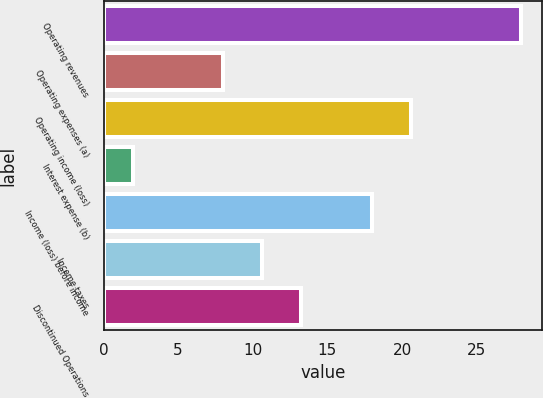Convert chart. <chart><loc_0><loc_0><loc_500><loc_500><bar_chart><fcel>Operating revenues<fcel>Operating expenses (a)<fcel>Operating income (loss)<fcel>Interest expense (b)<fcel>Income (loss) before income<fcel>Income taxes<fcel>Discontinued Operations<nl><fcel>28<fcel>8<fcel>20.6<fcel>2<fcel>18<fcel>10.6<fcel>13.2<nl></chart> 